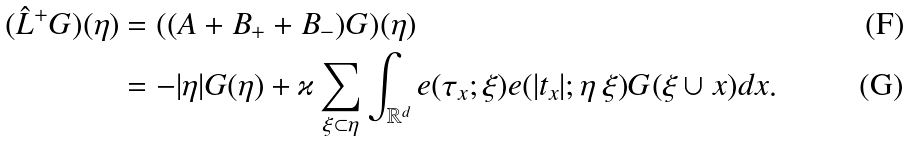Convert formula to latex. <formula><loc_0><loc_0><loc_500><loc_500>( \hat { L } ^ { + } G ) ( \eta ) & = ( ( A + B _ { + } + B _ { - } ) G ) ( \eta ) \\ & = - | \eta | G ( \eta ) + \varkappa \sum _ { \xi \subset \eta } \int _ { \mathbb { R } ^ { d } } e ( \tau _ { x } ; \xi ) e ( | t _ { x } | ; \eta \ \xi ) G ( \xi \cup x ) d x .</formula> 